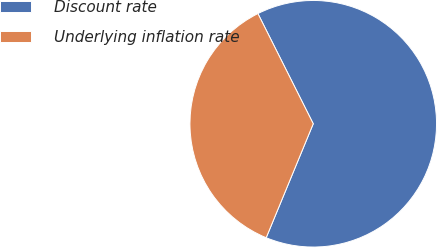Convert chart to OTSL. <chart><loc_0><loc_0><loc_500><loc_500><pie_chart><fcel>Discount rate<fcel>Underlying inflation rate<nl><fcel>63.64%<fcel>36.36%<nl></chart> 